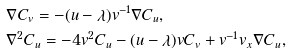Convert formula to latex. <formula><loc_0><loc_0><loc_500><loc_500>& \nabla C _ { v } = - ( u - \lambda ) v ^ { - 1 } \nabla C _ { u } , \\ & \nabla ^ { 2 } C _ { u } = - 4 v ^ { 2 } C _ { u } - ( u - \lambda ) v C _ { v } + v ^ { - 1 } v _ { x } \nabla C _ { u } ,</formula> 